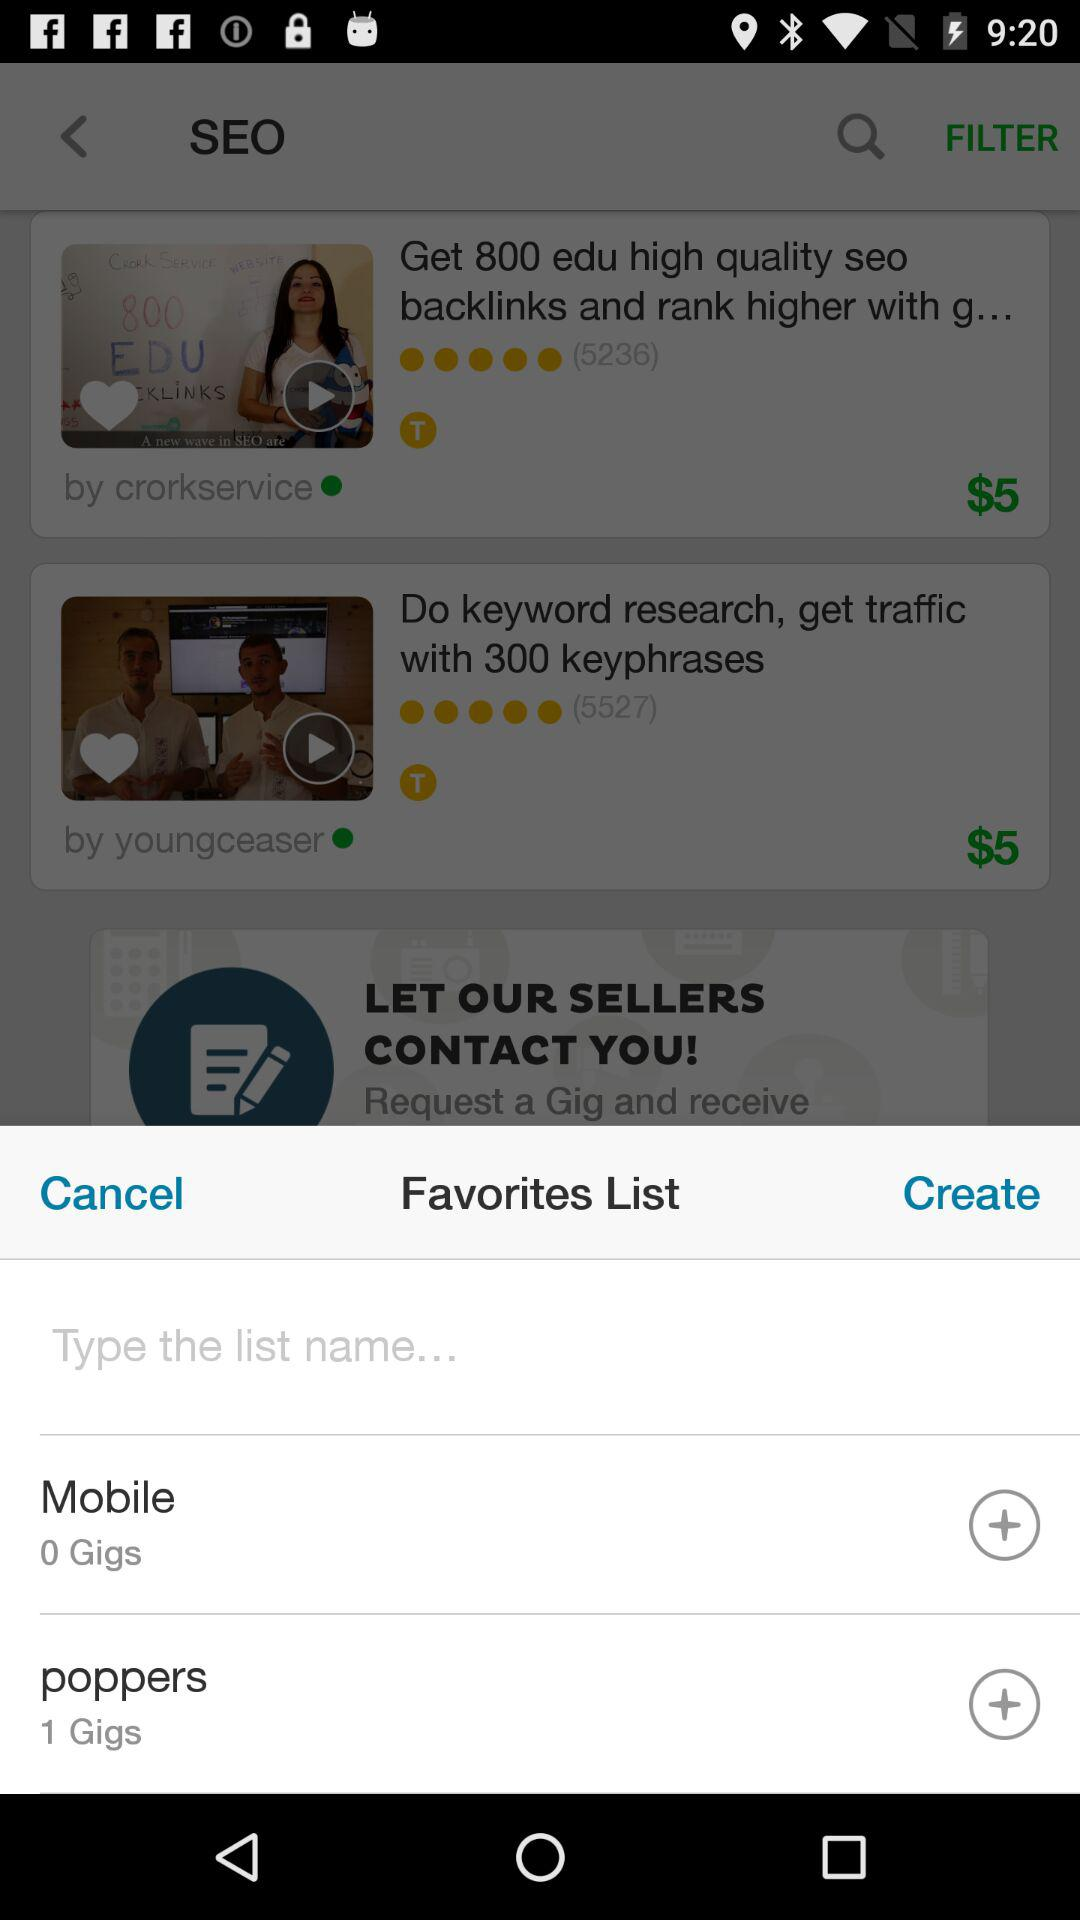What is the price of "Do keyword research, get traffic with 300 keyphrases"? The price is $5. 